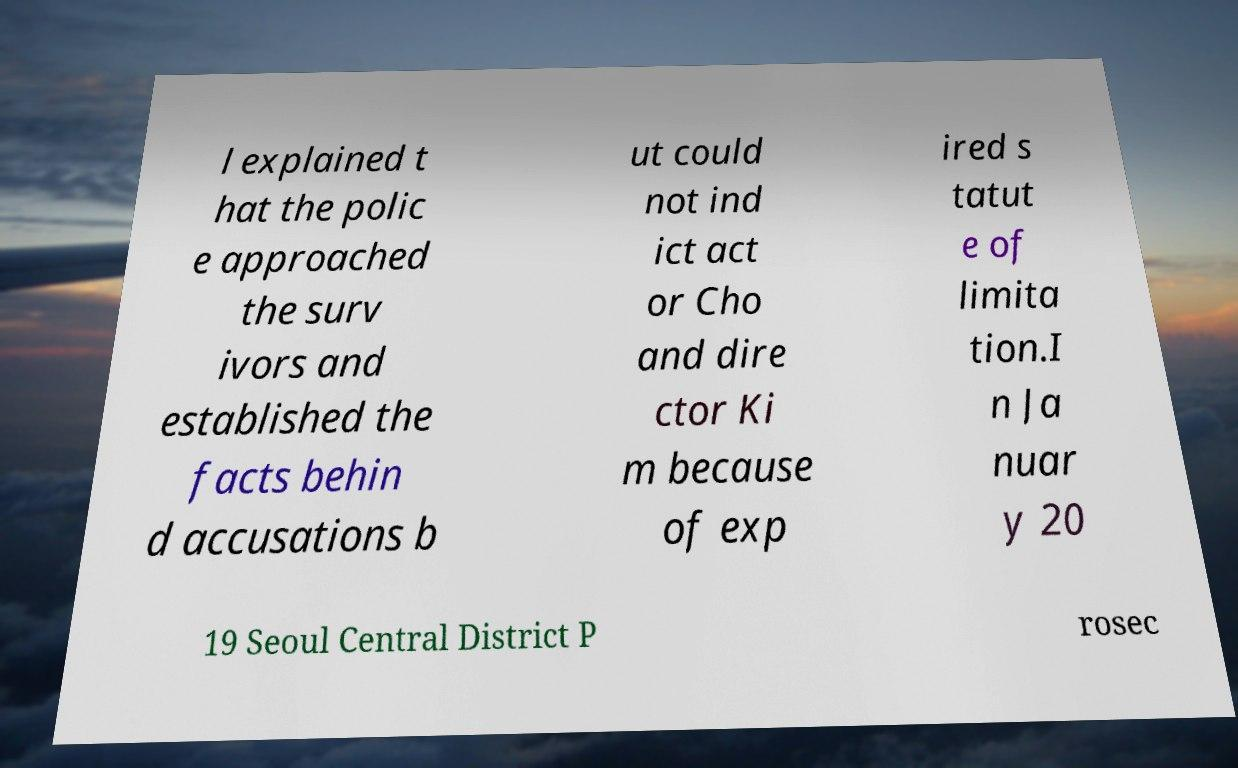Please read and relay the text visible in this image. What does it say? l explained t hat the polic e approached the surv ivors and established the facts behin d accusations b ut could not ind ict act or Cho and dire ctor Ki m because of exp ired s tatut e of limita tion.I n Ja nuar y 20 19 Seoul Central District P rosec 